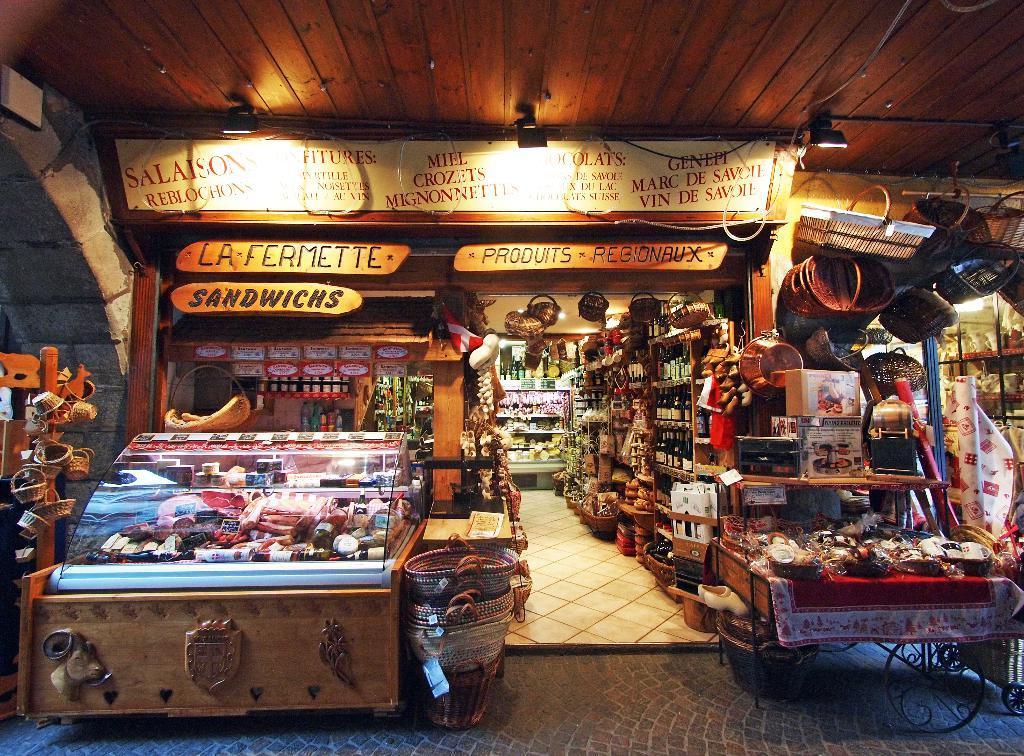<image>
Give a short and clear explanation of the subsequent image. The shop sells sandwiches along with other varieties of foods. 